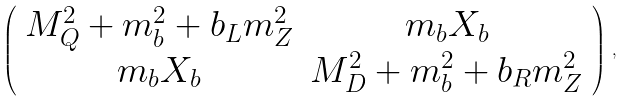<formula> <loc_0><loc_0><loc_500><loc_500>\left ( \begin{array} { c c } M _ { Q } ^ { 2 } + m _ { b } ^ { 2 } + b _ { L } m _ { Z } ^ { 2 } & m _ { b } X _ { b } \\ m _ { b } X _ { b } & M _ { D } ^ { 2 } + m _ { b } ^ { 2 } + b _ { R } m _ { Z } ^ { 2 } \end{array} \right ) \, ,</formula> 